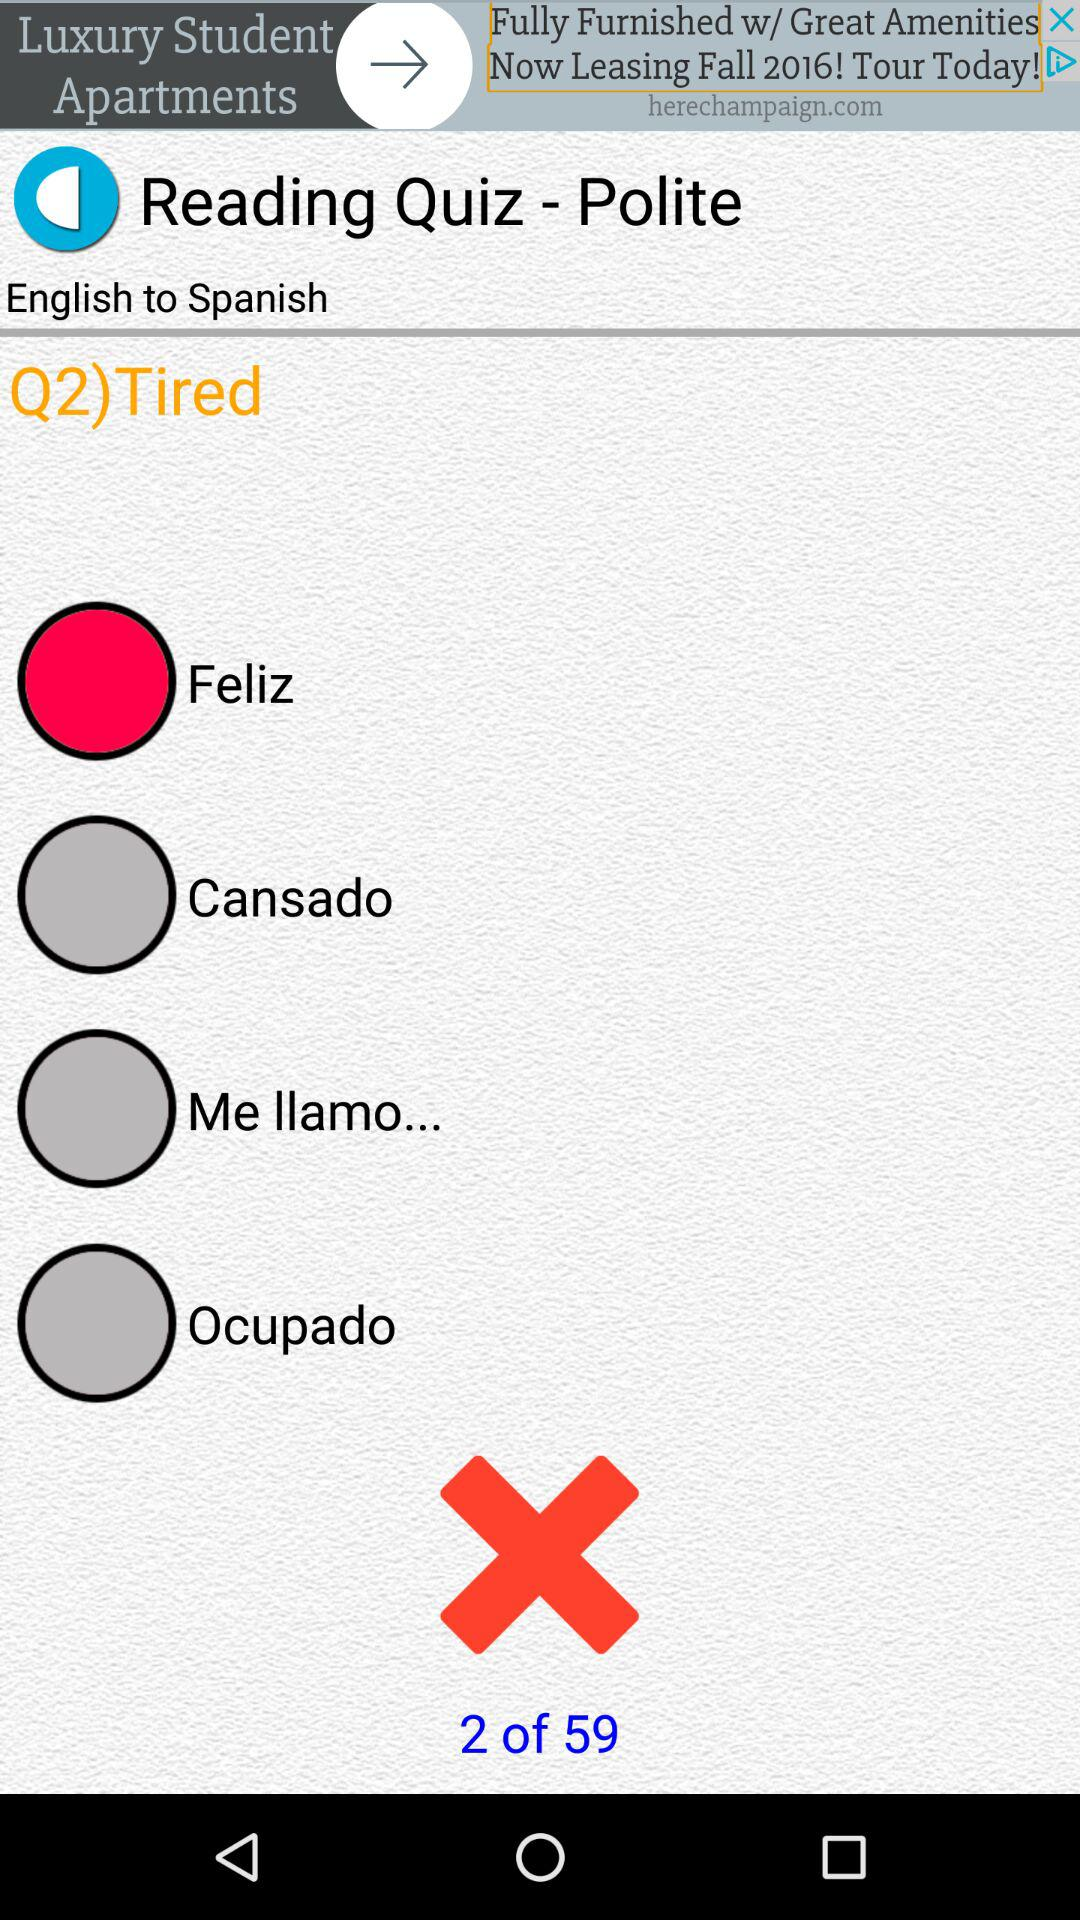How many slides are there? There are 59 slides. 